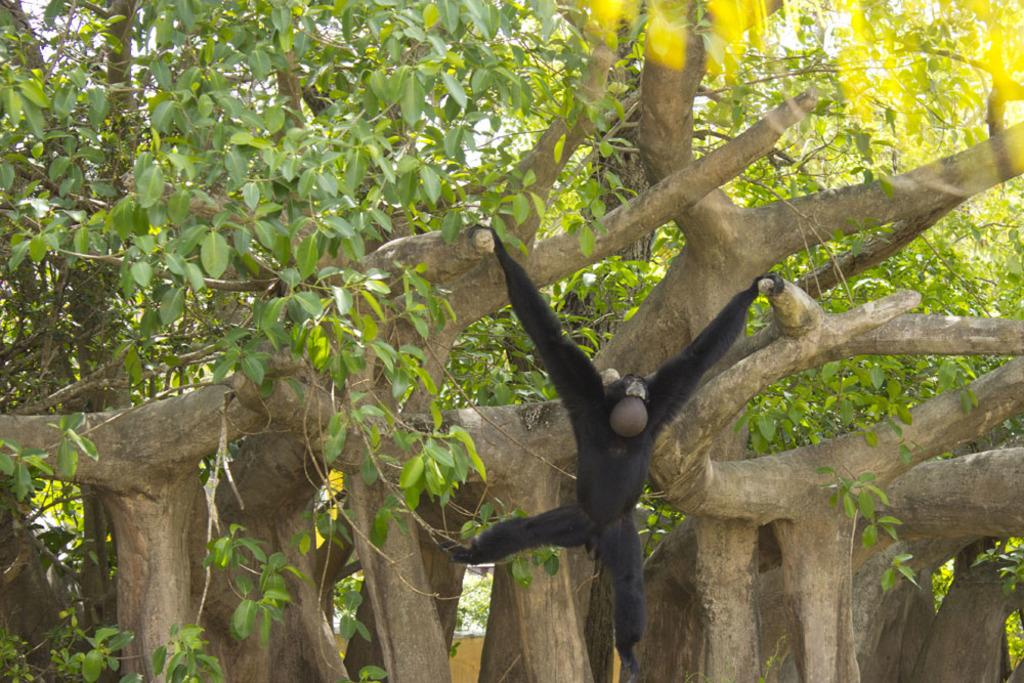What animal is the main subject of the image? There is a chimpanzee in the image. What is the chimpanzee doing in the image? The chimpanzee is climbing trees. What can be seen in the background of the image? There are trees in the background of the image. What type of bread is the chimpanzee holding in the image? There is no bread present in the image; the chimpanzee is climbing trees. Who is the daughter of the chimpanzee in the image? Chimpanzees do not have daughters, as they are not human. 